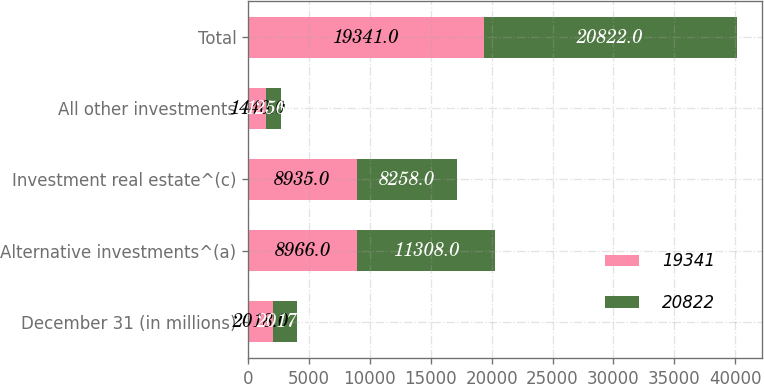<chart> <loc_0><loc_0><loc_500><loc_500><stacked_bar_chart><ecel><fcel>December 31 (in millions)<fcel>Alternative investments^(a)<fcel>Investment real estate^(c)<fcel>All other investments<fcel>Total<nl><fcel>19341<fcel>2018<fcel>8966<fcel>8935<fcel>1440<fcel>19341<nl><fcel>20822<fcel>2017<fcel>11308<fcel>8258<fcel>1256<fcel>20822<nl></chart> 